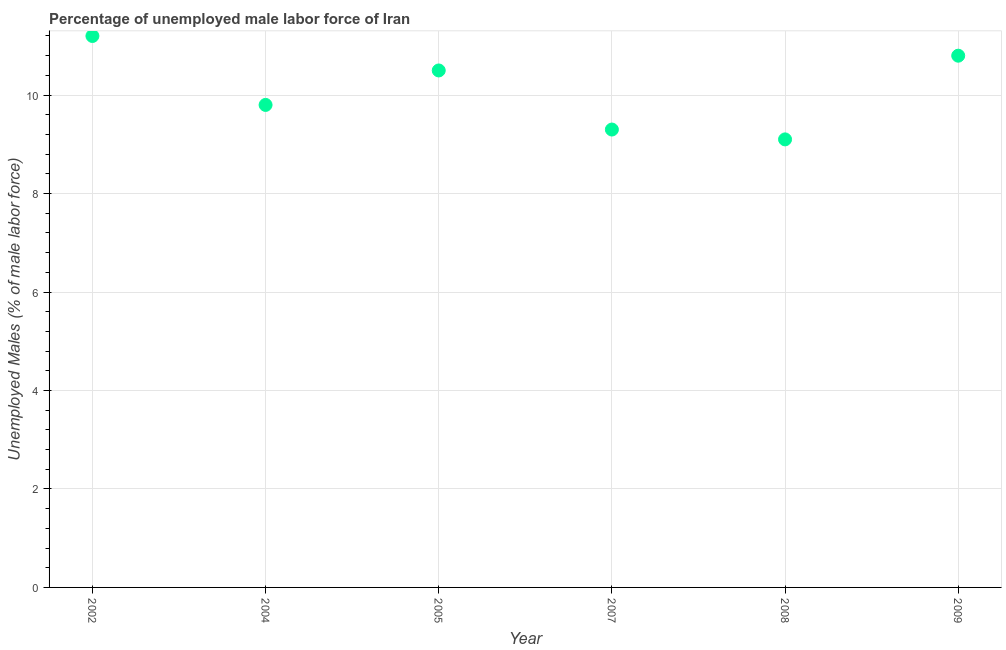Across all years, what is the maximum total unemployed male labour force?
Give a very brief answer. 11.2. Across all years, what is the minimum total unemployed male labour force?
Your answer should be compact. 9.1. What is the sum of the total unemployed male labour force?
Ensure brevity in your answer.  60.7. What is the difference between the total unemployed male labour force in 2007 and 2008?
Provide a short and direct response. 0.2. What is the average total unemployed male labour force per year?
Offer a very short reply. 10.12. What is the median total unemployed male labour force?
Ensure brevity in your answer.  10.15. Do a majority of the years between 2005 and 2002 (inclusive) have total unemployed male labour force greater than 0.8 %?
Your answer should be compact. No. What is the ratio of the total unemployed male labour force in 2007 to that in 2009?
Provide a short and direct response. 0.86. What is the difference between the highest and the second highest total unemployed male labour force?
Ensure brevity in your answer.  0.4. What is the difference between the highest and the lowest total unemployed male labour force?
Make the answer very short. 2.1. In how many years, is the total unemployed male labour force greater than the average total unemployed male labour force taken over all years?
Your answer should be very brief. 3. Does the total unemployed male labour force monotonically increase over the years?
Provide a succinct answer. No. What is the difference between two consecutive major ticks on the Y-axis?
Give a very brief answer. 2. Does the graph contain any zero values?
Make the answer very short. No. Does the graph contain grids?
Your answer should be compact. Yes. What is the title of the graph?
Ensure brevity in your answer.  Percentage of unemployed male labor force of Iran. What is the label or title of the X-axis?
Make the answer very short. Year. What is the label or title of the Y-axis?
Your response must be concise. Unemployed Males (% of male labor force). What is the Unemployed Males (% of male labor force) in 2002?
Your answer should be very brief. 11.2. What is the Unemployed Males (% of male labor force) in 2004?
Provide a short and direct response. 9.8. What is the Unemployed Males (% of male labor force) in 2007?
Make the answer very short. 9.3. What is the Unemployed Males (% of male labor force) in 2008?
Give a very brief answer. 9.1. What is the Unemployed Males (% of male labor force) in 2009?
Provide a succinct answer. 10.8. What is the difference between the Unemployed Males (% of male labor force) in 2002 and 2007?
Give a very brief answer. 1.9. What is the difference between the Unemployed Males (% of male labor force) in 2002 and 2009?
Your answer should be compact. 0.4. What is the difference between the Unemployed Males (% of male labor force) in 2004 and 2005?
Keep it short and to the point. -0.7. What is the difference between the Unemployed Males (% of male labor force) in 2004 and 2007?
Keep it short and to the point. 0.5. What is the difference between the Unemployed Males (% of male labor force) in 2004 and 2008?
Provide a short and direct response. 0.7. What is the difference between the Unemployed Males (% of male labor force) in 2005 and 2007?
Give a very brief answer. 1.2. What is the difference between the Unemployed Males (% of male labor force) in 2005 and 2008?
Your answer should be compact. 1.4. What is the difference between the Unemployed Males (% of male labor force) in 2008 and 2009?
Offer a very short reply. -1.7. What is the ratio of the Unemployed Males (% of male labor force) in 2002 to that in 2004?
Make the answer very short. 1.14. What is the ratio of the Unemployed Males (% of male labor force) in 2002 to that in 2005?
Your answer should be very brief. 1.07. What is the ratio of the Unemployed Males (% of male labor force) in 2002 to that in 2007?
Your answer should be very brief. 1.2. What is the ratio of the Unemployed Males (% of male labor force) in 2002 to that in 2008?
Ensure brevity in your answer.  1.23. What is the ratio of the Unemployed Males (% of male labor force) in 2004 to that in 2005?
Your response must be concise. 0.93. What is the ratio of the Unemployed Males (% of male labor force) in 2004 to that in 2007?
Provide a short and direct response. 1.05. What is the ratio of the Unemployed Males (% of male labor force) in 2004 to that in 2008?
Provide a succinct answer. 1.08. What is the ratio of the Unemployed Males (% of male labor force) in 2004 to that in 2009?
Offer a terse response. 0.91. What is the ratio of the Unemployed Males (% of male labor force) in 2005 to that in 2007?
Your answer should be very brief. 1.13. What is the ratio of the Unemployed Males (% of male labor force) in 2005 to that in 2008?
Keep it short and to the point. 1.15. What is the ratio of the Unemployed Males (% of male labor force) in 2007 to that in 2008?
Your response must be concise. 1.02. What is the ratio of the Unemployed Males (% of male labor force) in 2007 to that in 2009?
Offer a very short reply. 0.86. What is the ratio of the Unemployed Males (% of male labor force) in 2008 to that in 2009?
Keep it short and to the point. 0.84. 